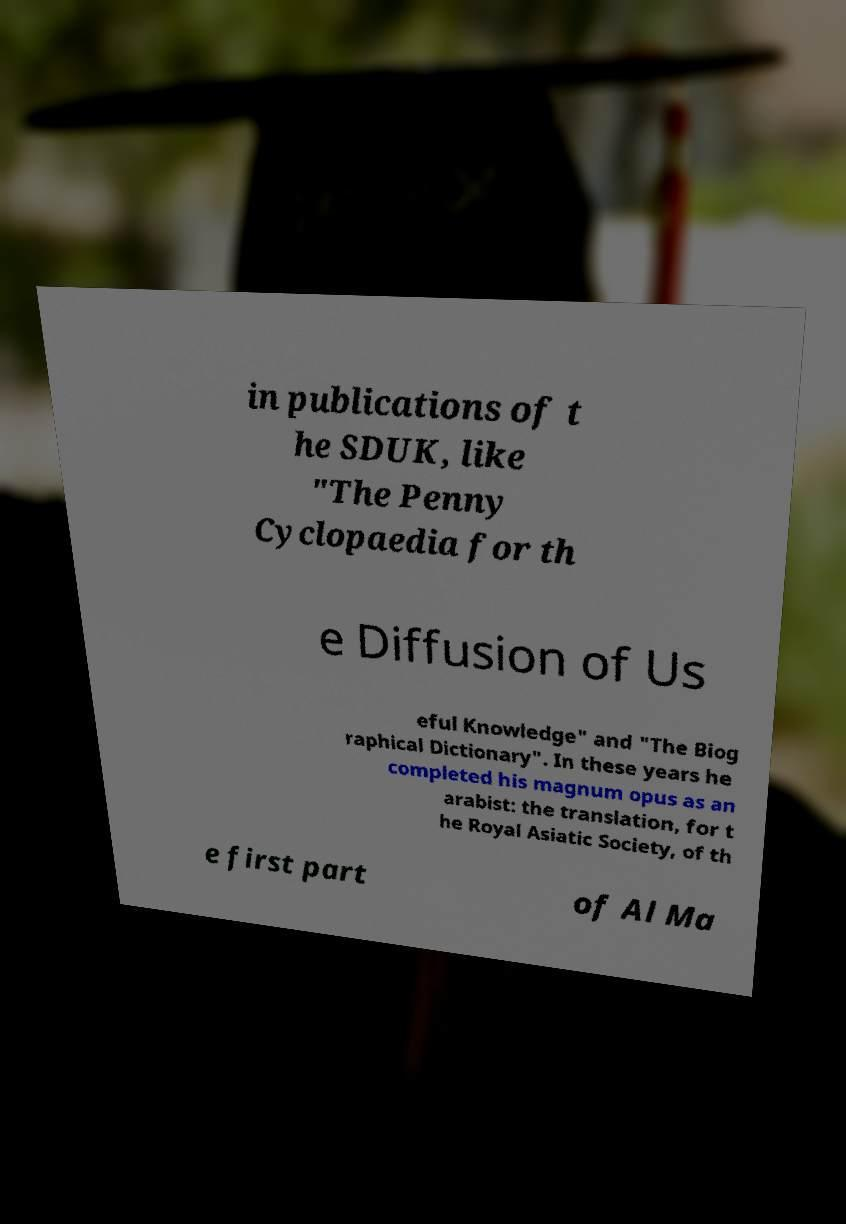There's text embedded in this image that I need extracted. Can you transcribe it verbatim? in publications of t he SDUK, like "The Penny Cyclopaedia for th e Diffusion of Us eful Knowledge" and "The Biog raphical Dictionary". In these years he completed his magnum opus as an arabist: the translation, for t he Royal Asiatic Society, of th e first part of Al Ma 